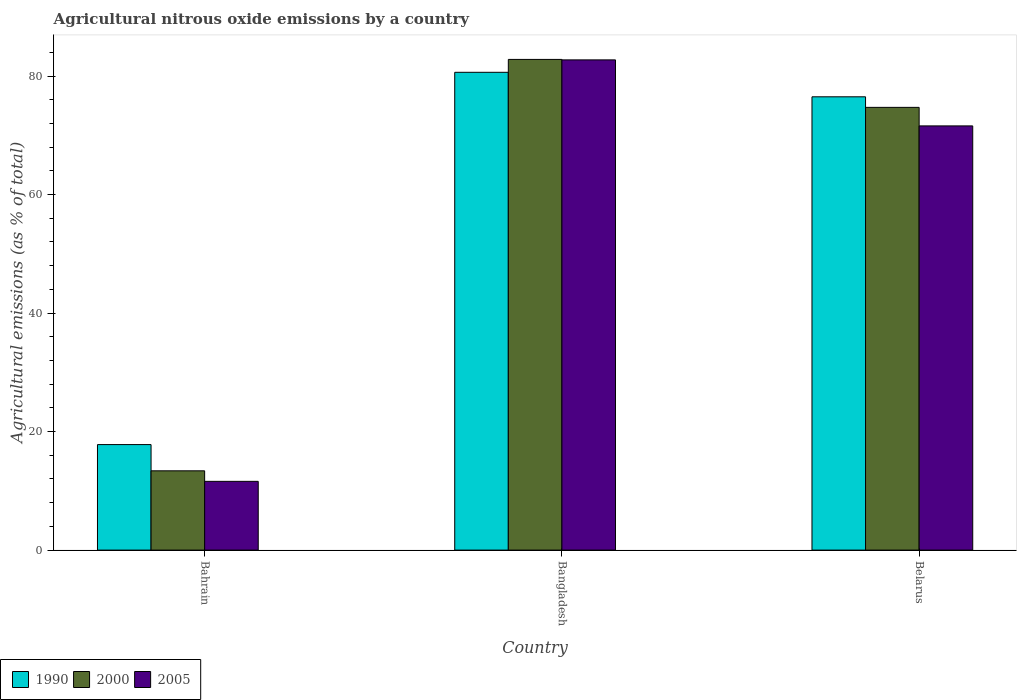How many groups of bars are there?
Give a very brief answer. 3. Are the number of bars per tick equal to the number of legend labels?
Give a very brief answer. Yes. What is the amount of agricultural nitrous oxide emitted in 2000 in Bahrain?
Provide a succinct answer. 13.38. Across all countries, what is the maximum amount of agricultural nitrous oxide emitted in 1990?
Make the answer very short. 80.63. Across all countries, what is the minimum amount of agricultural nitrous oxide emitted in 2005?
Offer a terse response. 11.6. In which country was the amount of agricultural nitrous oxide emitted in 2005 maximum?
Ensure brevity in your answer.  Bangladesh. In which country was the amount of agricultural nitrous oxide emitted in 2000 minimum?
Your answer should be compact. Bahrain. What is the total amount of agricultural nitrous oxide emitted in 2005 in the graph?
Provide a succinct answer. 165.92. What is the difference between the amount of agricultural nitrous oxide emitted in 2000 in Bahrain and that in Bangladesh?
Your response must be concise. -69.43. What is the difference between the amount of agricultural nitrous oxide emitted in 2005 in Bangladesh and the amount of agricultural nitrous oxide emitted in 2000 in Belarus?
Your answer should be compact. 8.01. What is the average amount of agricultural nitrous oxide emitted in 1990 per country?
Your answer should be compact. 58.31. What is the difference between the amount of agricultural nitrous oxide emitted of/in 1990 and amount of agricultural nitrous oxide emitted of/in 2005 in Bangladesh?
Keep it short and to the point. -2.1. In how many countries, is the amount of agricultural nitrous oxide emitted in 2005 greater than 24 %?
Your answer should be compact. 2. What is the ratio of the amount of agricultural nitrous oxide emitted in 1990 in Bahrain to that in Belarus?
Ensure brevity in your answer.  0.23. What is the difference between the highest and the second highest amount of agricultural nitrous oxide emitted in 2005?
Provide a short and direct response. 71.13. What is the difference between the highest and the lowest amount of agricultural nitrous oxide emitted in 2005?
Make the answer very short. 71.13. In how many countries, is the amount of agricultural nitrous oxide emitted in 2005 greater than the average amount of agricultural nitrous oxide emitted in 2005 taken over all countries?
Make the answer very short. 2. What does the 1st bar from the left in Bahrain represents?
Offer a terse response. 1990. Is it the case that in every country, the sum of the amount of agricultural nitrous oxide emitted in 2005 and amount of agricultural nitrous oxide emitted in 2000 is greater than the amount of agricultural nitrous oxide emitted in 1990?
Your answer should be compact. Yes. How many countries are there in the graph?
Give a very brief answer. 3. What is the difference between two consecutive major ticks on the Y-axis?
Your answer should be compact. 20. Does the graph contain any zero values?
Your response must be concise. No. What is the title of the graph?
Your response must be concise. Agricultural nitrous oxide emissions by a country. Does "1996" appear as one of the legend labels in the graph?
Your answer should be very brief. No. What is the label or title of the X-axis?
Ensure brevity in your answer.  Country. What is the label or title of the Y-axis?
Provide a short and direct response. Agricultural emissions (as % of total). What is the Agricultural emissions (as % of total) in 1990 in Bahrain?
Offer a very short reply. 17.81. What is the Agricultural emissions (as % of total) in 2000 in Bahrain?
Offer a terse response. 13.38. What is the Agricultural emissions (as % of total) of 2005 in Bahrain?
Provide a succinct answer. 11.6. What is the Agricultural emissions (as % of total) of 1990 in Bangladesh?
Provide a short and direct response. 80.63. What is the Agricultural emissions (as % of total) of 2000 in Bangladesh?
Give a very brief answer. 82.81. What is the Agricultural emissions (as % of total) in 2005 in Bangladesh?
Give a very brief answer. 82.73. What is the Agricultural emissions (as % of total) in 1990 in Belarus?
Offer a very short reply. 76.5. What is the Agricultural emissions (as % of total) in 2000 in Belarus?
Offer a terse response. 74.72. What is the Agricultural emissions (as % of total) in 2005 in Belarus?
Keep it short and to the point. 71.59. Across all countries, what is the maximum Agricultural emissions (as % of total) of 1990?
Offer a terse response. 80.63. Across all countries, what is the maximum Agricultural emissions (as % of total) in 2000?
Offer a terse response. 82.81. Across all countries, what is the maximum Agricultural emissions (as % of total) in 2005?
Make the answer very short. 82.73. Across all countries, what is the minimum Agricultural emissions (as % of total) in 1990?
Your answer should be compact. 17.81. Across all countries, what is the minimum Agricultural emissions (as % of total) in 2000?
Your response must be concise. 13.38. Across all countries, what is the minimum Agricultural emissions (as % of total) of 2005?
Make the answer very short. 11.6. What is the total Agricultural emissions (as % of total) of 1990 in the graph?
Provide a short and direct response. 174.94. What is the total Agricultural emissions (as % of total) of 2000 in the graph?
Keep it short and to the point. 170.9. What is the total Agricultural emissions (as % of total) in 2005 in the graph?
Give a very brief answer. 165.92. What is the difference between the Agricultural emissions (as % of total) in 1990 in Bahrain and that in Bangladesh?
Your response must be concise. -62.83. What is the difference between the Agricultural emissions (as % of total) in 2000 in Bahrain and that in Bangladesh?
Your answer should be very brief. -69.43. What is the difference between the Agricultural emissions (as % of total) in 2005 in Bahrain and that in Bangladesh?
Offer a very short reply. -71.13. What is the difference between the Agricultural emissions (as % of total) in 1990 in Bahrain and that in Belarus?
Your answer should be compact. -58.69. What is the difference between the Agricultural emissions (as % of total) of 2000 in Bahrain and that in Belarus?
Your answer should be very brief. -61.34. What is the difference between the Agricultural emissions (as % of total) of 2005 in Bahrain and that in Belarus?
Your answer should be compact. -59.98. What is the difference between the Agricultural emissions (as % of total) of 1990 in Bangladesh and that in Belarus?
Provide a succinct answer. 4.13. What is the difference between the Agricultural emissions (as % of total) in 2000 in Bangladesh and that in Belarus?
Your answer should be very brief. 8.09. What is the difference between the Agricultural emissions (as % of total) in 2005 in Bangladesh and that in Belarus?
Make the answer very short. 11.14. What is the difference between the Agricultural emissions (as % of total) in 1990 in Bahrain and the Agricultural emissions (as % of total) in 2000 in Bangladesh?
Your response must be concise. -65. What is the difference between the Agricultural emissions (as % of total) in 1990 in Bahrain and the Agricultural emissions (as % of total) in 2005 in Bangladesh?
Make the answer very short. -64.92. What is the difference between the Agricultural emissions (as % of total) in 2000 in Bahrain and the Agricultural emissions (as % of total) in 2005 in Bangladesh?
Your answer should be very brief. -69.35. What is the difference between the Agricultural emissions (as % of total) of 1990 in Bahrain and the Agricultural emissions (as % of total) of 2000 in Belarus?
Offer a terse response. -56.91. What is the difference between the Agricultural emissions (as % of total) of 1990 in Bahrain and the Agricultural emissions (as % of total) of 2005 in Belarus?
Provide a short and direct response. -53.78. What is the difference between the Agricultural emissions (as % of total) of 2000 in Bahrain and the Agricultural emissions (as % of total) of 2005 in Belarus?
Your answer should be very brief. -58.21. What is the difference between the Agricultural emissions (as % of total) in 1990 in Bangladesh and the Agricultural emissions (as % of total) in 2000 in Belarus?
Make the answer very short. 5.92. What is the difference between the Agricultural emissions (as % of total) of 1990 in Bangladesh and the Agricultural emissions (as % of total) of 2005 in Belarus?
Make the answer very short. 9.04. What is the difference between the Agricultural emissions (as % of total) of 2000 in Bangladesh and the Agricultural emissions (as % of total) of 2005 in Belarus?
Your response must be concise. 11.22. What is the average Agricultural emissions (as % of total) of 1990 per country?
Ensure brevity in your answer.  58.31. What is the average Agricultural emissions (as % of total) in 2000 per country?
Provide a succinct answer. 56.97. What is the average Agricultural emissions (as % of total) in 2005 per country?
Make the answer very short. 55.31. What is the difference between the Agricultural emissions (as % of total) in 1990 and Agricultural emissions (as % of total) in 2000 in Bahrain?
Provide a succinct answer. 4.43. What is the difference between the Agricultural emissions (as % of total) in 1990 and Agricultural emissions (as % of total) in 2005 in Bahrain?
Your response must be concise. 6.2. What is the difference between the Agricultural emissions (as % of total) in 2000 and Agricultural emissions (as % of total) in 2005 in Bahrain?
Your answer should be very brief. 1.78. What is the difference between the Agricultural emissions (as % of total) of 1990 and Agricultural emissions (as % of total) of 2000 in Bangladesh?
Keep it short and to the point. -2.18. What is the difference between the Agricultural emissions (as % of total) in 1990 and Agricultural emissions (as % of total) in 2005 in Bangladesh?
Provide a short and direct response. -2.1. What is the difference between the Agricultural emissions (as % of total) in 2000 and Agricultural emissions (as % of total) in 2005 in Bangladesh?
Give a very brief answer. 0.08. What is the difference between the Agricultural emissions (as % of total) in 1990 and Agricultural emissions (as % of total) in 2000 in Belarus?
Your response must be concise. 1.78. What is the difference between the Agricultural emissions (as % of total) of 1990 and Agricultural emissions (as % of total) of 2005 in Belarus?
Provide a short and direct response. 4.91. What is the difference between the Agricultural emissions (as % of total) of 2000 and Agricultural emissions (as % of total) of 2005 in Belarus?
Provide a succinct answer. 3.13. What is the ratio of the Agricultural emissions (as % of total) in 1990 in Bahrain to that in Bangladesh?
Ensure brevity in your answer.  0.22. What is the ratio of the Agricultural emissions (as % of total) in 2000 in Bahrain to that in Bangladesh?
Make the answer very short. 0.16. What is the ratio of the Agricultural emissions (as % of total) in 2005 in Bahrain to that in Bangladesh?
Offer a terse response. 0.14. What is the ratio of the Agricultural emissions (as % of total) in 1990 in Bahrain to that in Belarus?
Offer a very short reply. 0.23. What is the ratio of the Agricultural emissions (as % of total) in 2000 in Bahrain to that in Belarus?
Offer a terse response. 0.18. What is the ratio of the Agricultural emissions (as % of total) of 2005 in Bahrain to that in Belarus?
Provide a succinct answer. 0.16. What is the ratio of the Agricultural emissions (as % of total) in 1990 in Bangladesh to that in Belarus?
Your answer should be compact. 1.05. What is the ratio of the Agricultural emissions (as % of total) of 2000 in Bangladesh to that in Belarus?
Ensure brevity in your answer.  1.11. What is the ratio of the Agricultural emissions (as % of total) of 2005 in Bangladesh to that in Belarus?
Your answer should be compact. 1.16. What is the difference between the highest and the second highest Agricultural emissions (as % of total) in 1990?
Ensure brevity in your answer.  4.13. What is the difference between the highest and the second highest Agricultural emissions (as % of total) in 2000?
Your response must be concise. 8.09. What is the difference between the highest and the second highest Agricultural emissions (as % of total) in 2005?
Ensure brevity in your answer.  11.14. What is the difference between the highest and the lowest Agricultural emissions (as % of total) of 1990?
Your response must be concise. 62.83. What is the difference between the highest and the lowest Agricultural emissions (as % of total) in 2000?
Make the answer very short. 69.43. What is the difference between the highest and the lowest Agricultural emissions (as % of total) of 2005?
Keep it short and to the point. 71.13. 